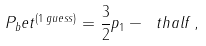<formula> <loc_0><loc_0><loc_500><loc_500>P _ { b } e t ^ { ( 1 \, g u e s s ) } = \frac { 3 } { 2 } p _ { 1 } - \ t h a l f \, ,</formula> 